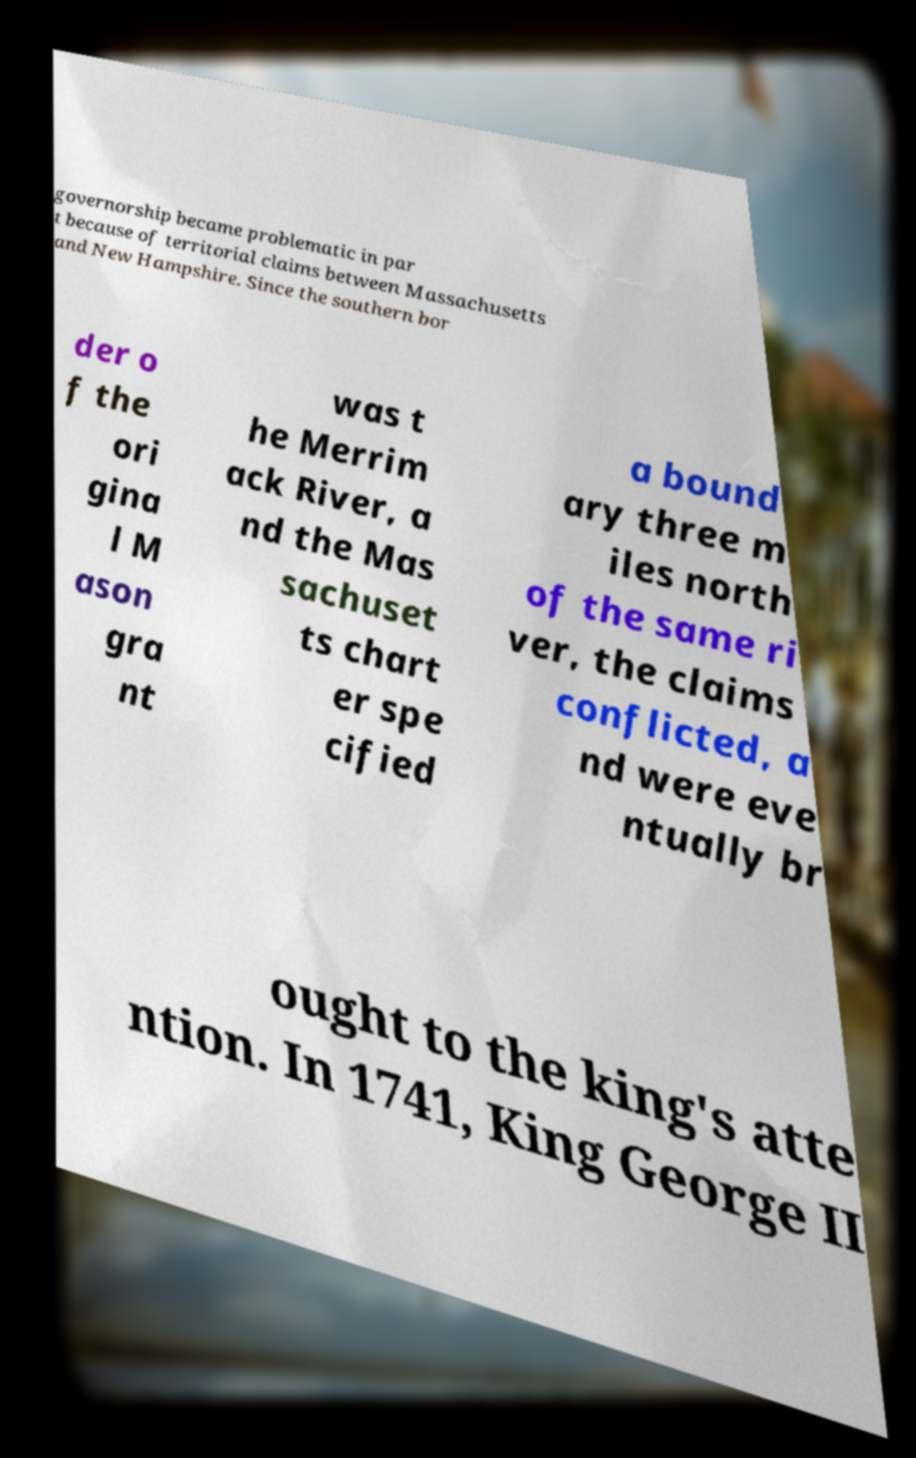Could you extract and type out the text from this image? governorship became problematic in par t because of territorial claims between Massachusetts and New Hampshire. Since the southern bor der o f the ori gina l M ason gra nt was t he Merrim ack River, a nd the Mas sachuset ts chart er spe cified a bound ary three m iles north of the same ri ver, the claims conflicted, a nd were eve ntually br ought to the king's atte ntion. In 1741, King George II 